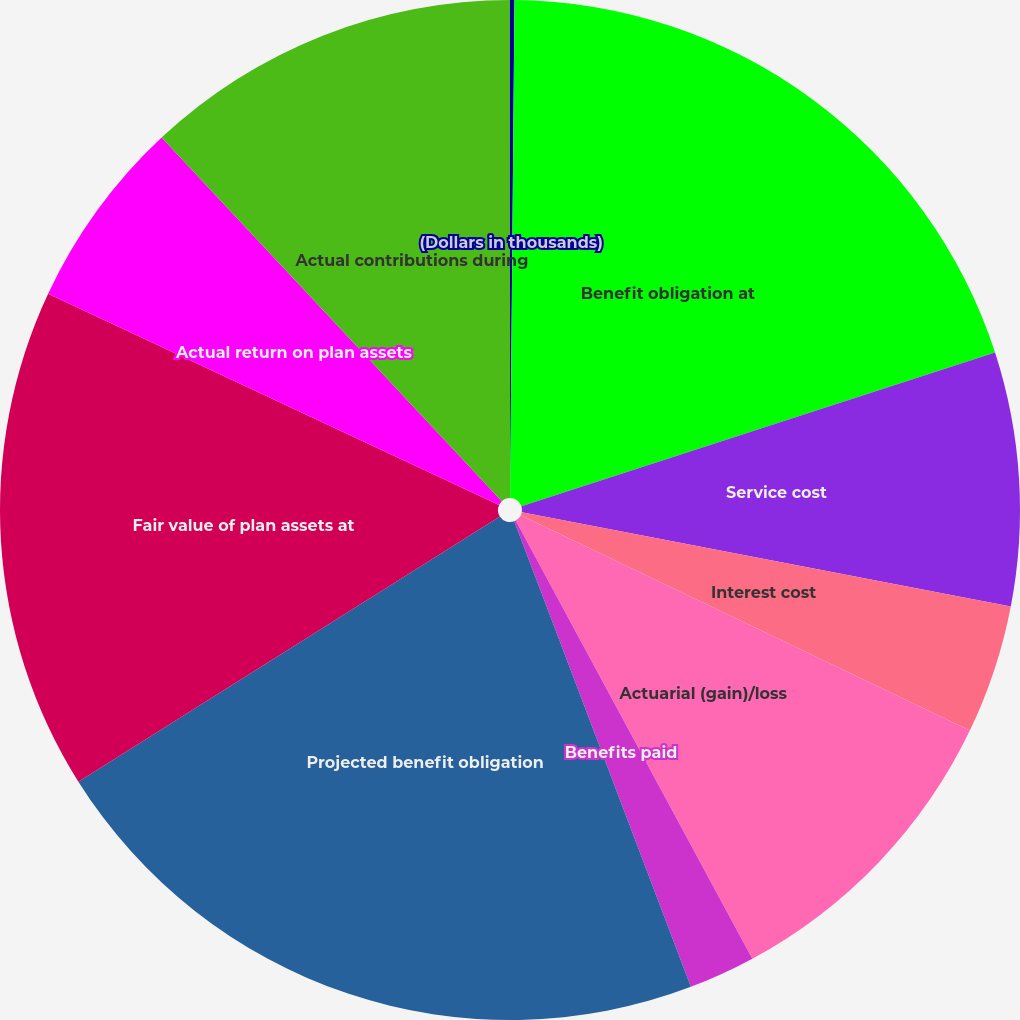Convert chart to OTSL. <chart><loc_0><loc_0><loc_500><loc_500><pie_chart><fcel>(Dollars in thousands)<fcel>Benefit obligation at<fcel>Service cost<fcel>Interest cost<fcel>Actuarial (gain)/loss<fcel>Benefits paid<fcel>Projected benefit obligation<fcel>Fair value of plan assets at<fcel>Actual return on plan assets<fcel>Actual contributions during<nl><fcel>0.14%<fcel>19.86%<fcel>8.03%<fcel>4.09%<fcel>10.0%<fcel>2.11%<fcel>21.83%<fcel>15.91%<fcel>6.06%<fcel>11.97%<nl></chart> 